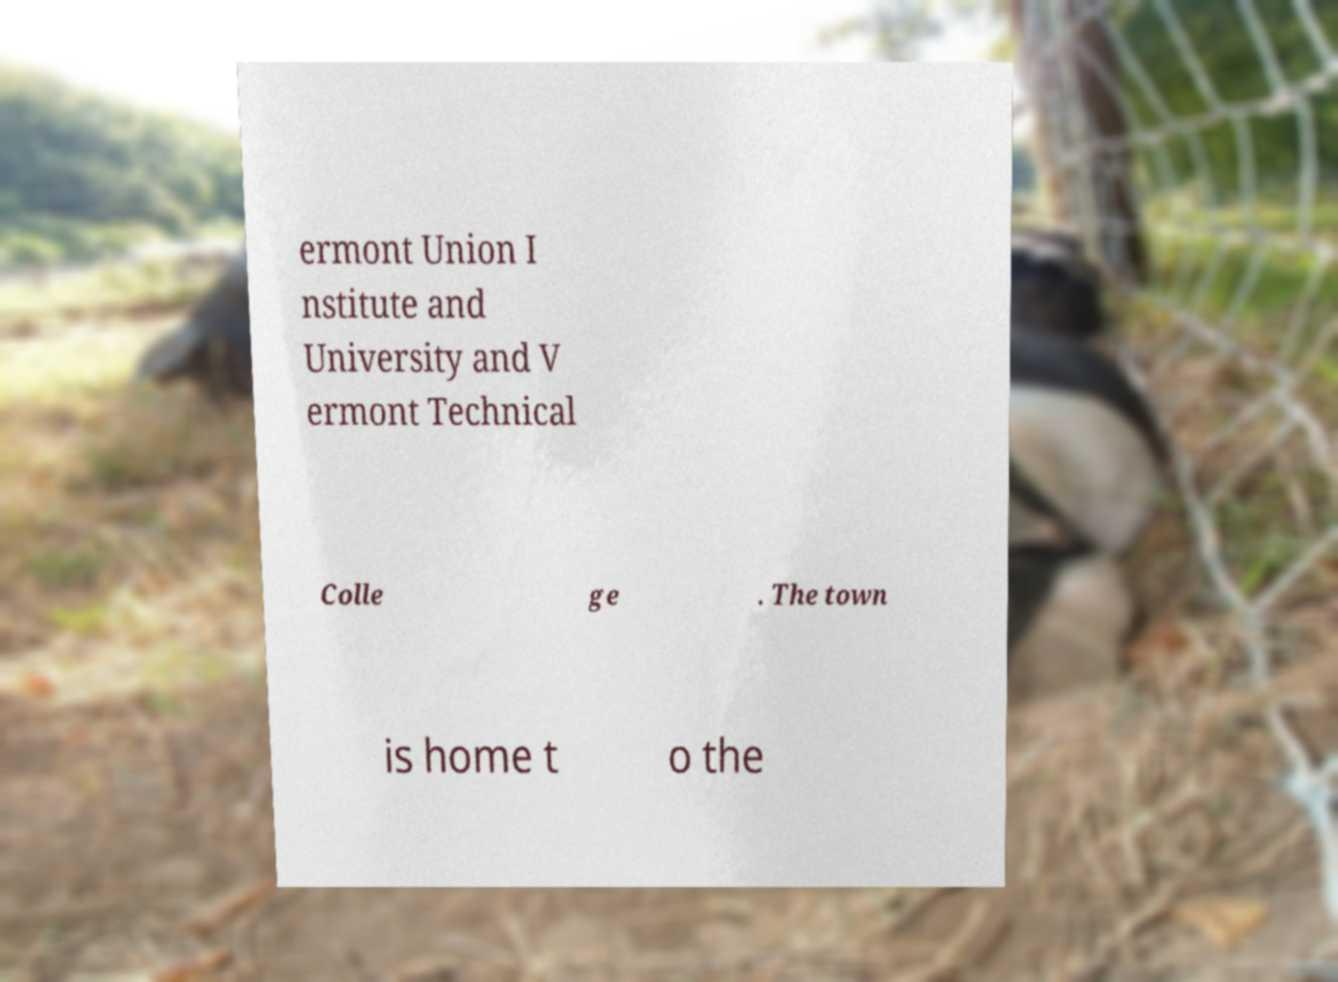There's text embedded in this image that I need extracted. Can you transcribe it verbatim? ermont Union I nstitute and University and V ermont Technical Colle ge . The town is home t o the 